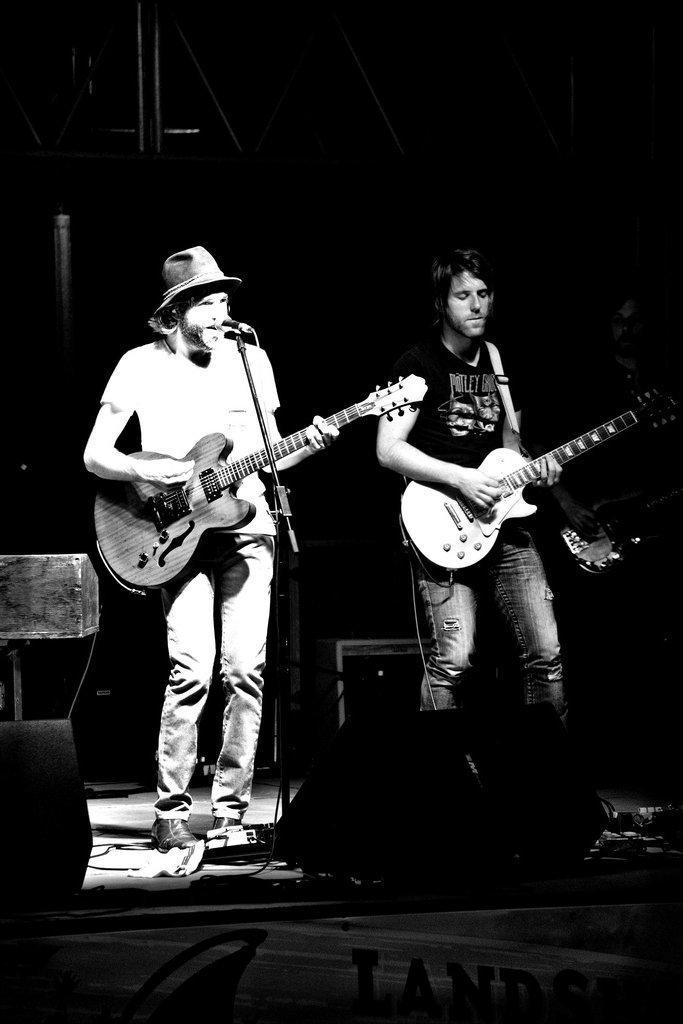Could you give a brief overview of what you see in this image? In this picture there are two people, those who are playing the guitar on the stage and there is a mic at the center of the image, there is a speaker at the center of the image. 